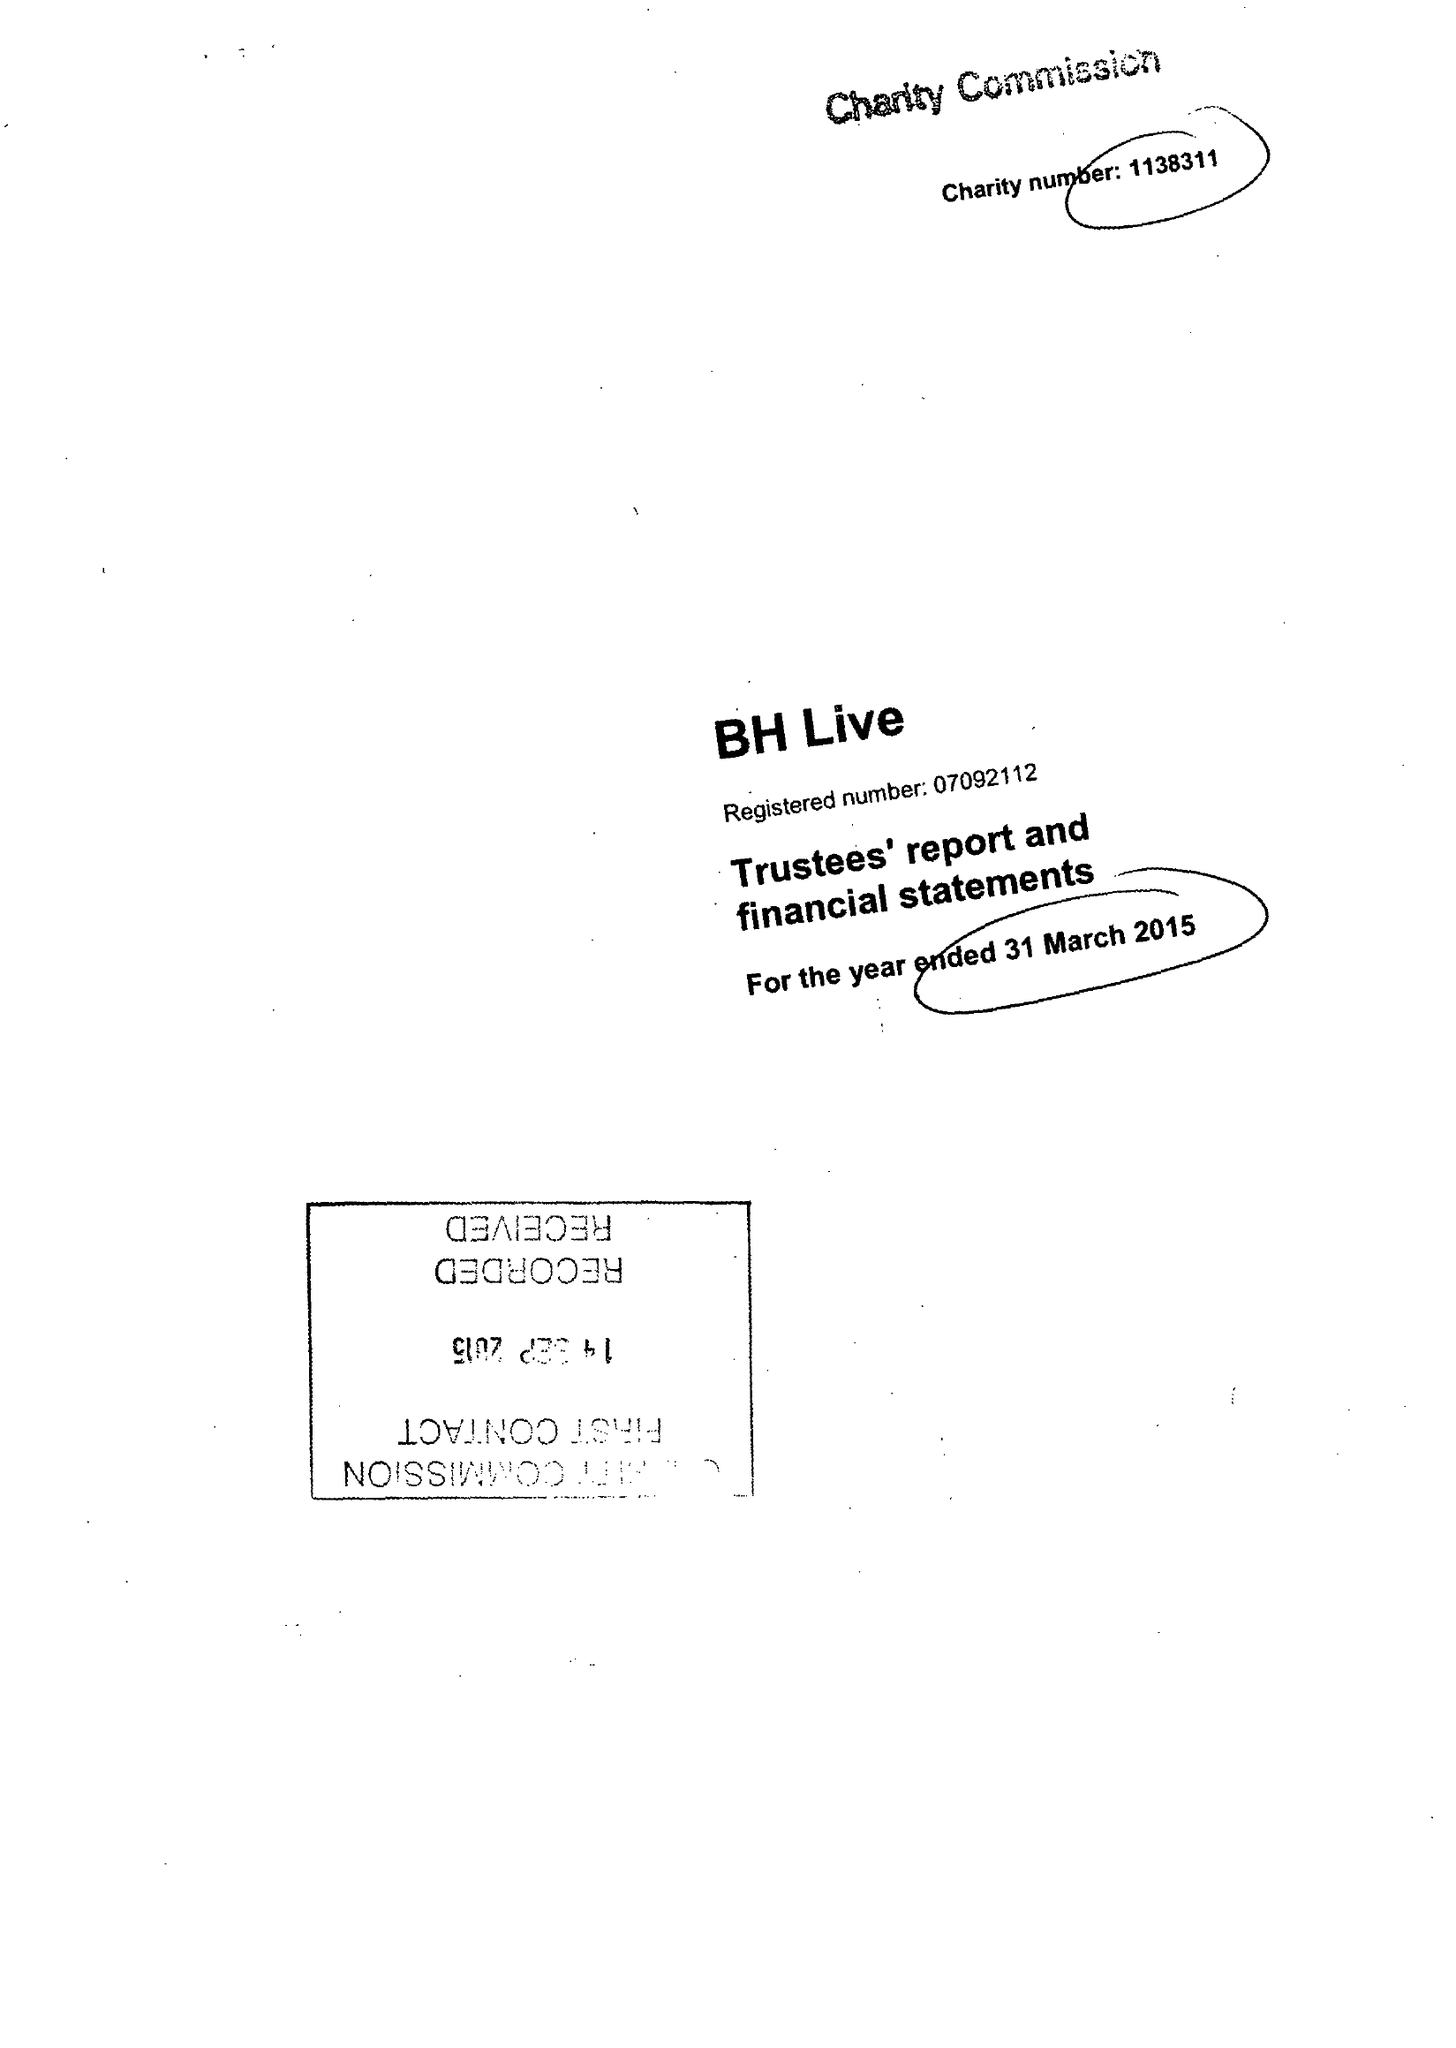What is the value for the address__postcode?
Answer the question using a single word or phrase. BH2 5BH 